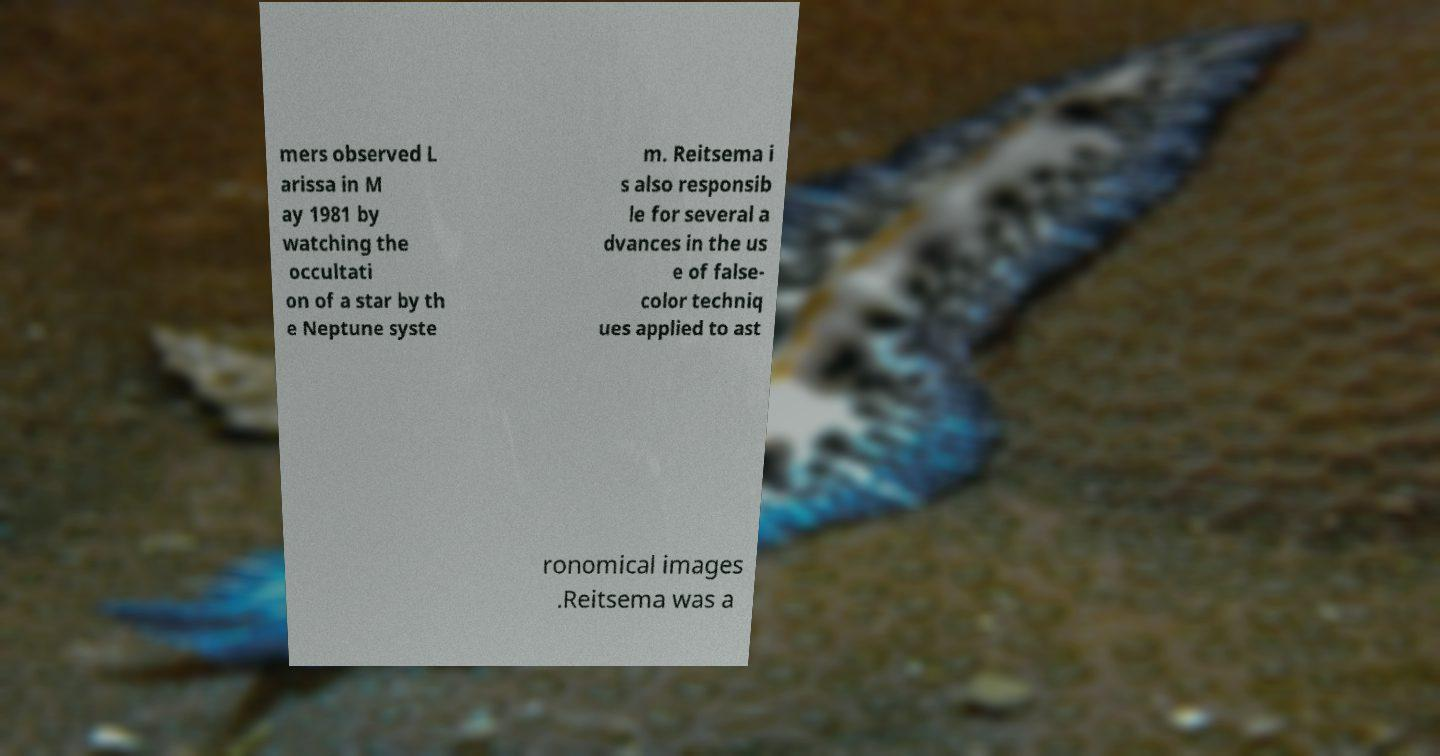Could you extract and type out the text from this image? mers observed L arissa in M ay 1981 by watching the occultati on of a star by th e Neptune syste m. Reitsema i s also responsib le for several a dvances in the us e of false- color techniq ues applied to ast ronomical images .Reitsema was a 